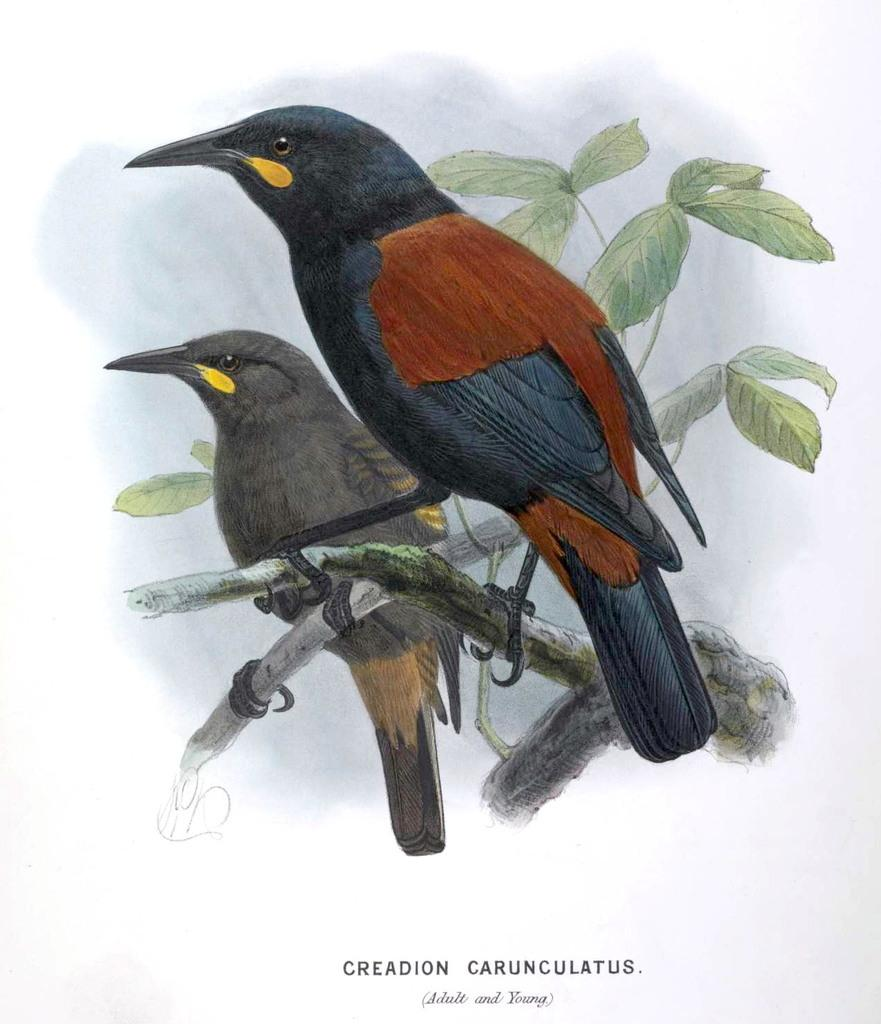What type of artwork is depicted in the image? The image is a painting. What animals can be seen in the painting? There are two birds in the painting. Where are the birds located in the painting? The birds are on a tree. How many toes does the toad have in the painting? There is no toad present in the painting; it features two birds on a tree. 